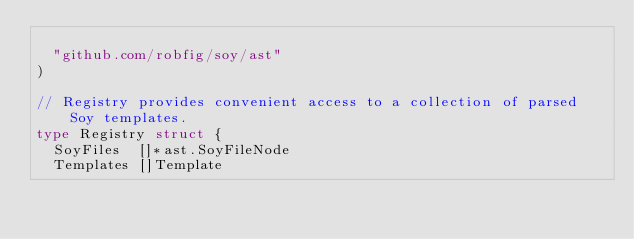<code> <loc_0><loc_0><loc_500><loc_500><_Go_>
	"github.com/robfig/soy/ast"
)

// Registry provides convenient access to a collection of parsed Soy templates.
type Registry struct {
	SoyFiles  []*ast.SoyFileNode
	Templates []Template
</code> 